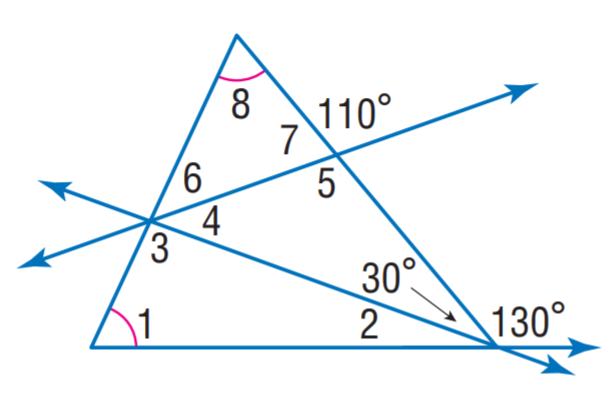Answer the mathemtical geometry problem and directly provide the correct option letter.
Question: Find m \angle 6.
Choices: A: 30 B: 40 C: 45 D: 65 C 